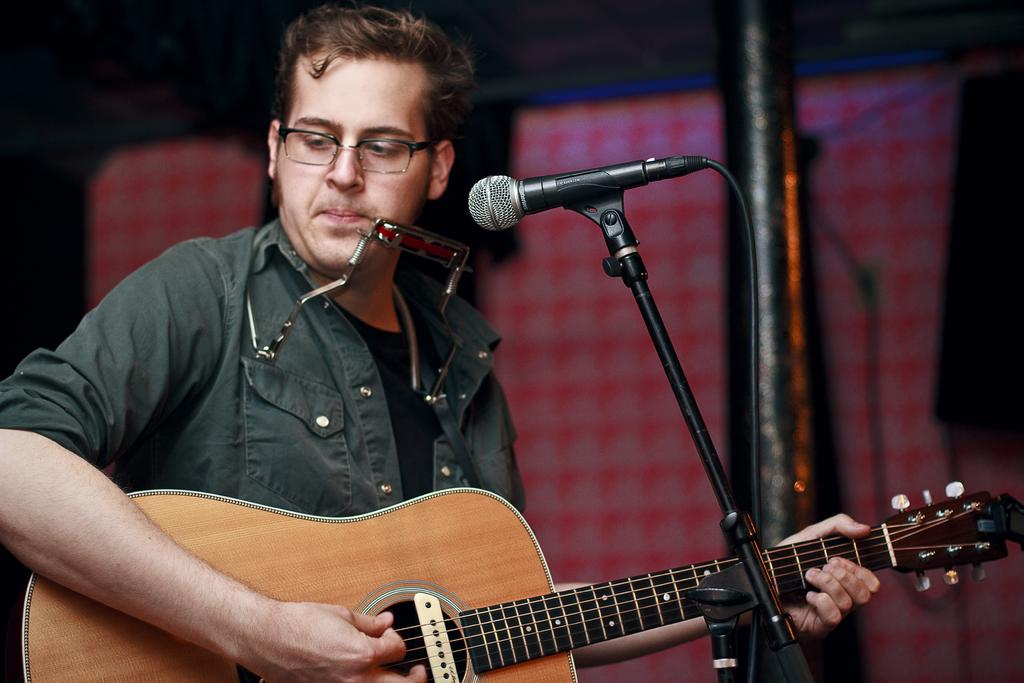What is the person in the image doing? The person is holding a guitar and singing. What object is in front of the person? There is a microphone in front of the person. What type of copper material is being used for writing in the image? There is no copper material or writing activity present in the image. 